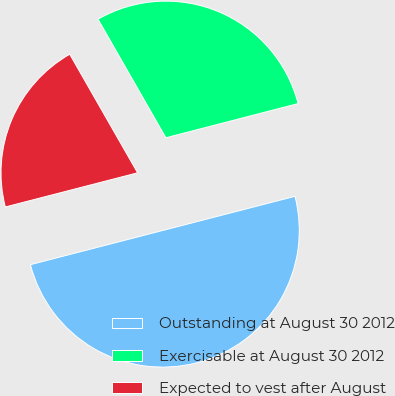<chart> <loc_0><loc_0><loc_500><loc_500><pie_chart><fcel>Outstanding at August 30 2012<fcel>Exercisable at August 30 2012<fcel>Expected to vest after August<nl><fcel>50.0%<fcel>29.25%<fcel>20.75%<nl></chart> 